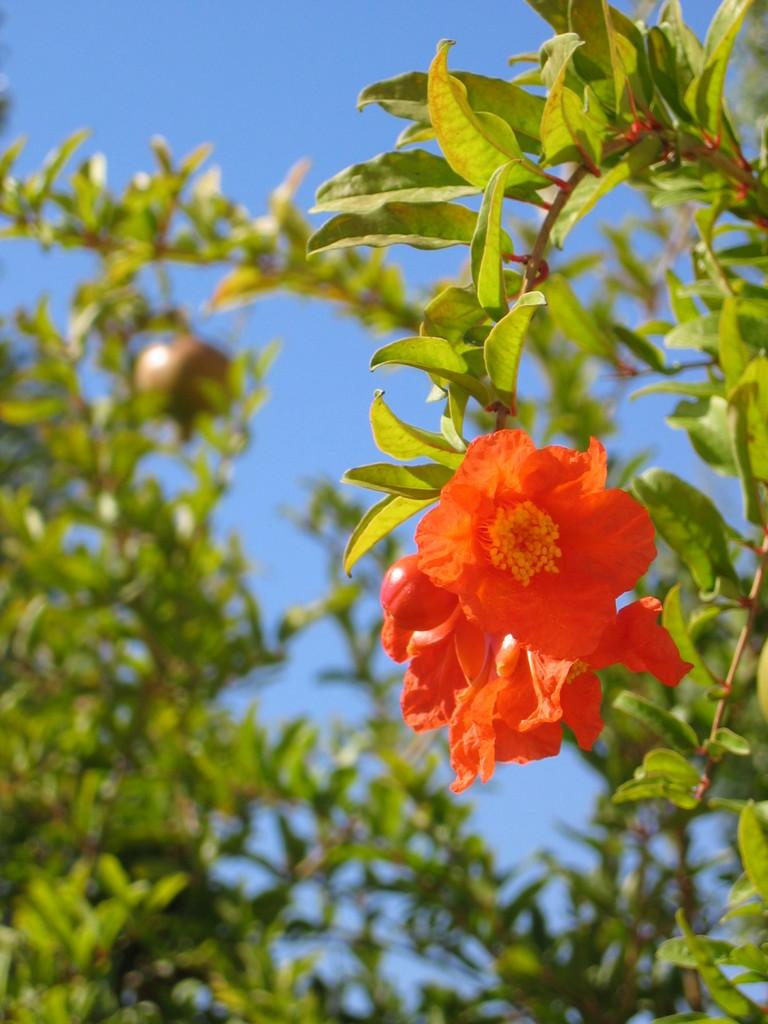What is located in the foreground of the image? There are flowers and a pomegranate tree in the foreground of the image. What can be seen in the background of the image? The sky is visible in the background of the image. What type of curtain can be seen hanging from the pomegranate tree in the image? There is no curtain present in the image, as it features flowers and a pomegranate tree in the foreground and the sky in the background. 